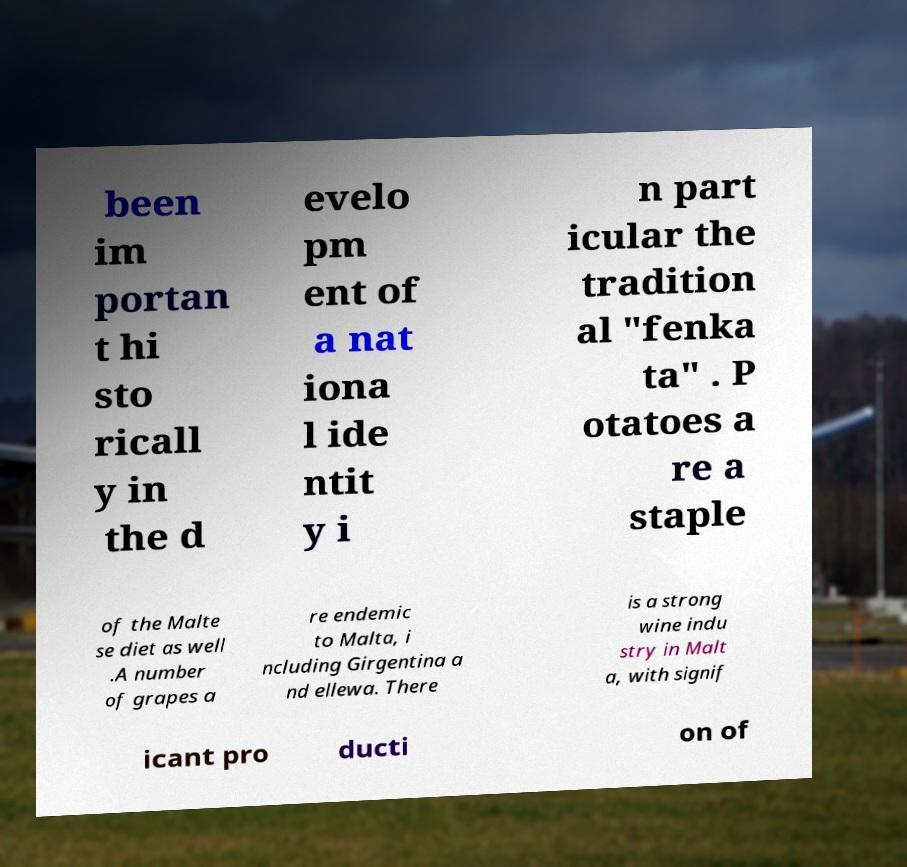There's text embedded in this image that I need extracted. Can you transcribe it verbatim? been im portan t hi sto ricall y in the d evelo pm ent of a nat iona l ide ntit y i n part icular the tradition al "fenka ta" . P otatoes a re a staple of the Malte se diet as well .A number of grapes a re endemic to Malta, i ncluding Girgentina a nd ellewa. There is a strong wine indu stry in Malt a, with signif icant pro ducti on of 